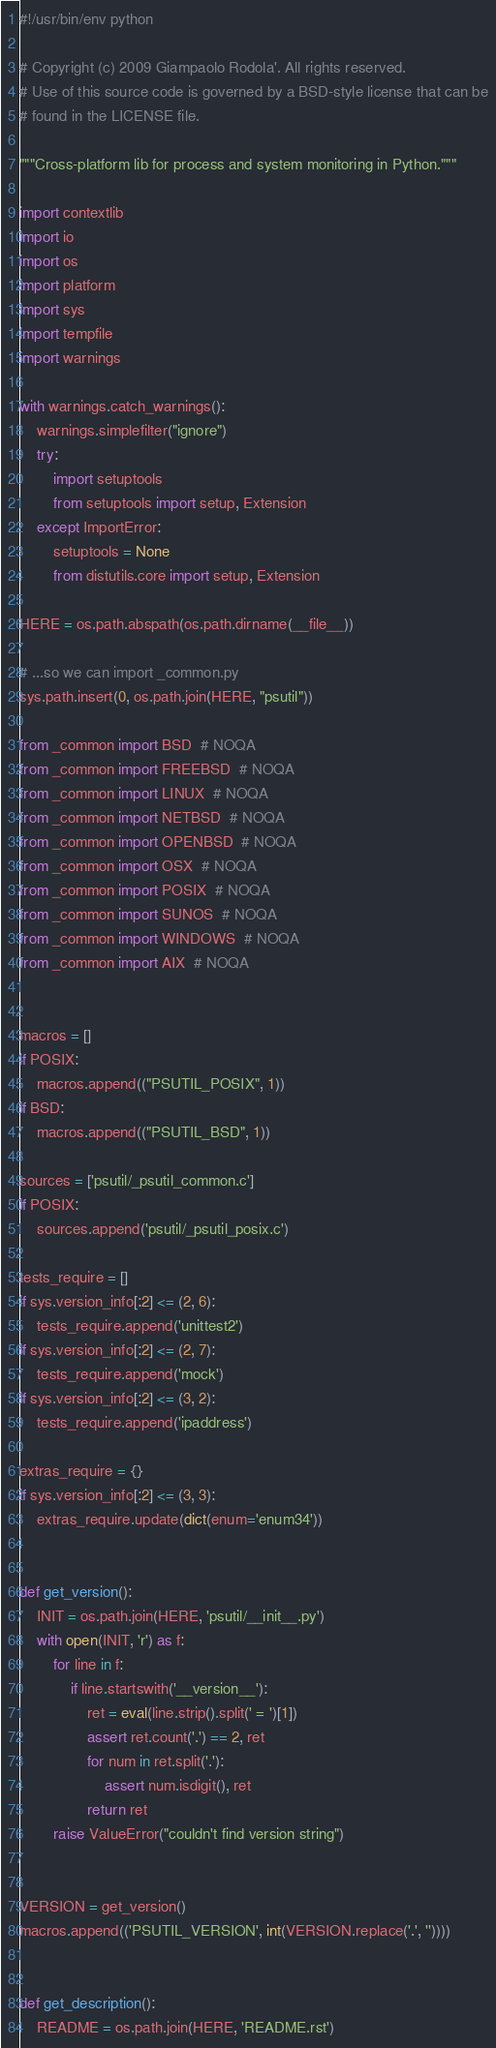Convert code to text. <code><loc_0><loc_0><loc_500><loc_500><_Python_>#!/usr/bin/env python

# Copyright (c) 2009 Giampaolo Rodola'. All rights reserved.
# Use of this source code is governed by a BSD-style license that can be
# found in the LICENSE file.

"""Cross-platform lib for process and system monitoring in Python."""

import contextlib
import io
import os
import platform
import sys
import tempfile
import warnings

with warnings.catch_warnings():
    warnings.simplefilter("ignore")
    try:
        import setuptools
        from setuptools import setup, Extension
    except ImportError:
        setuptools = None
        from distutils.core import setup, Extension

HERE = os.path.abspath(os.path.dirname(__file__))

# ...so we can import _common.py
sys.path.insert(0, os.path.join(HERE, "psutil"))

from _common import BSD  # NOQA
from _common import FREEBSD  # NOQA
from _common import LINUX  # NOQA
from _common import NETBSD  # NOQA
from _common import OPENBSD  # NOQA
from _common import OSX  # NOQA
from _common import POSIX  # NOQA
from _common import SUNOS  # NOQA
from _common import WINDOWS  # NOQA
from _common import AIX  # NOQA


macros = []
if POSIX:
    macros.append(("PSUTIL_POSIX", 1))
if BSD:
    macros.append(("PSUTIL_BSD", 1))

sources = ['psutil/_psutil_common.c']
if POSIX:
    sources.append('psutil/_psutil_posix.c')

tests_require = []
if sys.version_info[:2] <= (2, 6):
    tests_require.append('unittest2')
if sys.version_info[:2] <= (2, 7):
    tests_require.append('mock')
if sys.version_info[:2] <= (3, 2):
    tests_require.append('ipaddress')

extras_require = {}
if sys.version_info[:2] <= (3, 3):
    extras_require.update(dict(enum='enum34'))


def get_version():
    INIT = os.path.join(HERE, 'psutil/__init__.py')
    with open(INIT, 'r') as f:
        for line in f:
            if line.startswith('__version__'):
                ret = eval(line.strip().split(' = ')[1])
                assert ret.count('.') == 2, ret
                for num in ret.split('.'):
                    assert num.isdigit(), ret
                return ret
        raise ValueError("couldn't find version string")


VERSION = get_version()
macros.append(('PSUTIL_VERSION', int(VERSION.replace('.', ''))))


def get_description():
    README = os.path.join(HERE, 'README.rst')</code> 